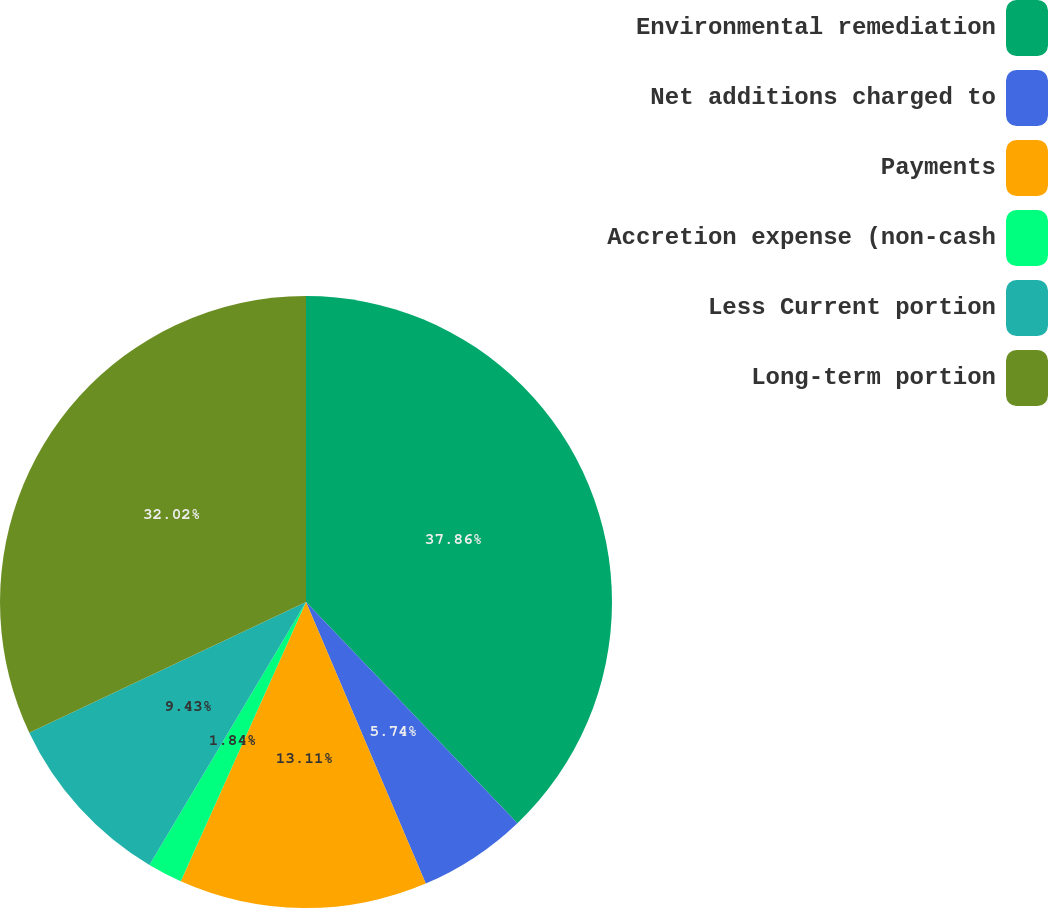Convert chart. <chart><loc_0><loc_0><loc_500><loc_500><pie_chart><fcel>Environmental remediation<fcel>Net additions charged to<fcel>Payments<fcel>Accretion expense (non-cash<fcel>Less Current portion<fcel>Long-term portion<nl><fcel>37.86%<fcel>5.74%<fcel>13.11%<fcel>1.84%<fcel>9.43%<fcel>32.02%<nl></chart> 